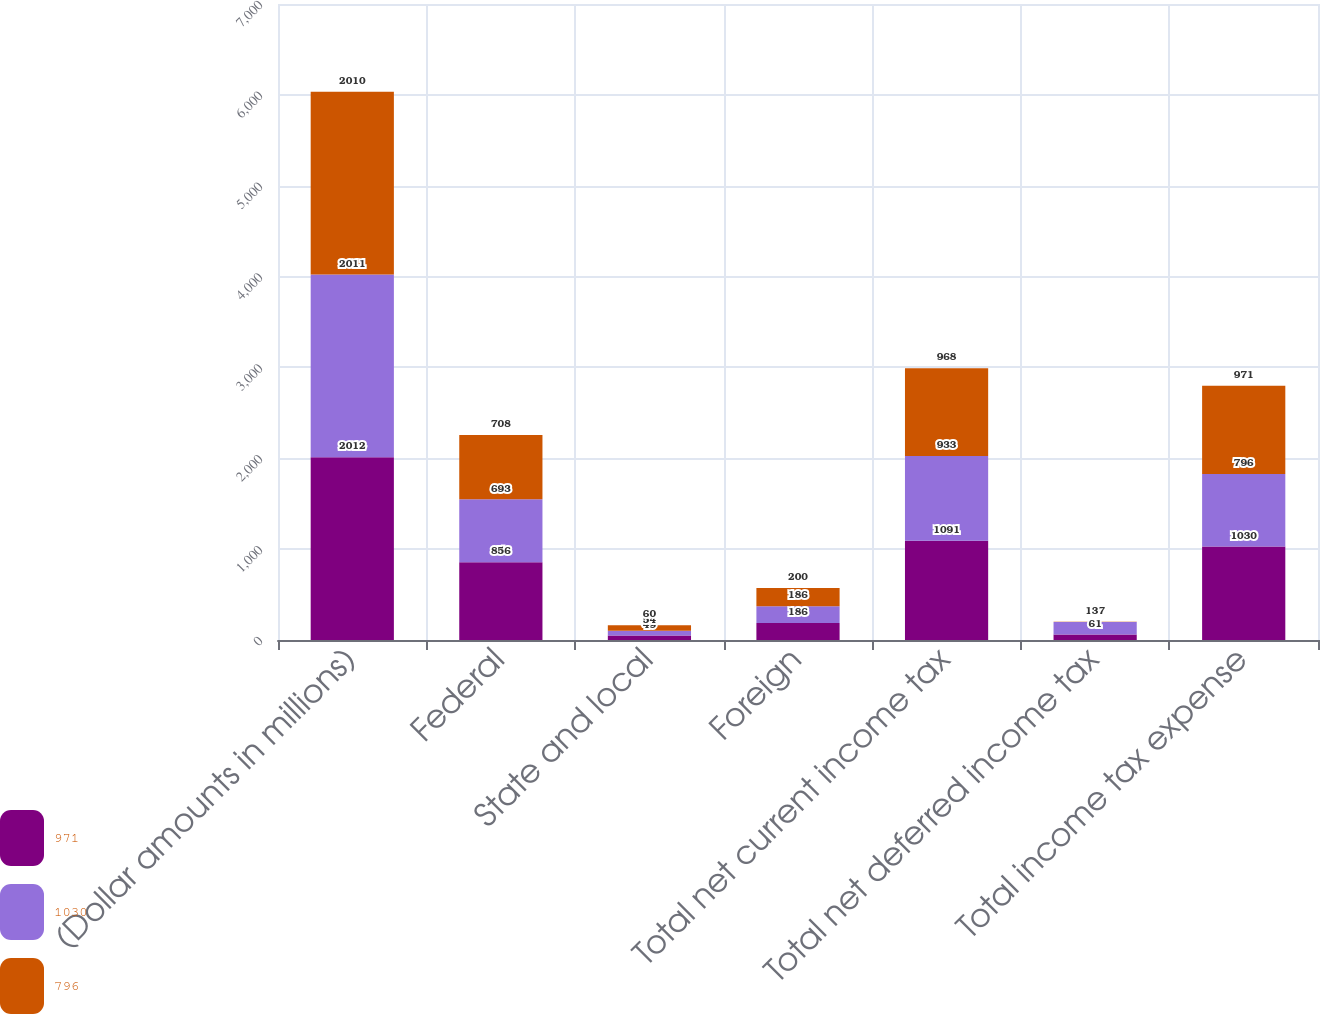Convert chart to OTSL. <chart><loc_0><loc_0><loc_500><loc_500><stacked_bar_chart><ecel><fcel>(Dollar amounts in millions)<fcel>Federal<fcel>State and local<fcel>Foreign<fcel>Total net current income tax<fcel>Total net deferred income tax<fcel>Total income tax expense<nl><fcel>971<fcel>2012<fcel>856<fcel>49<fcel>186<fcel>1091<fcel>61<fcel>1030<nl><fcel>1030<fcel>2011<fcel>693<fcel>54<fcel>186<fcel>933<fcel>137<fcel>796<nl><fcel>796<fcel>2010<fcel>708<fcel>60<fcel>200<fcel>968<fcel>3<fcel>971<nl></chart> 